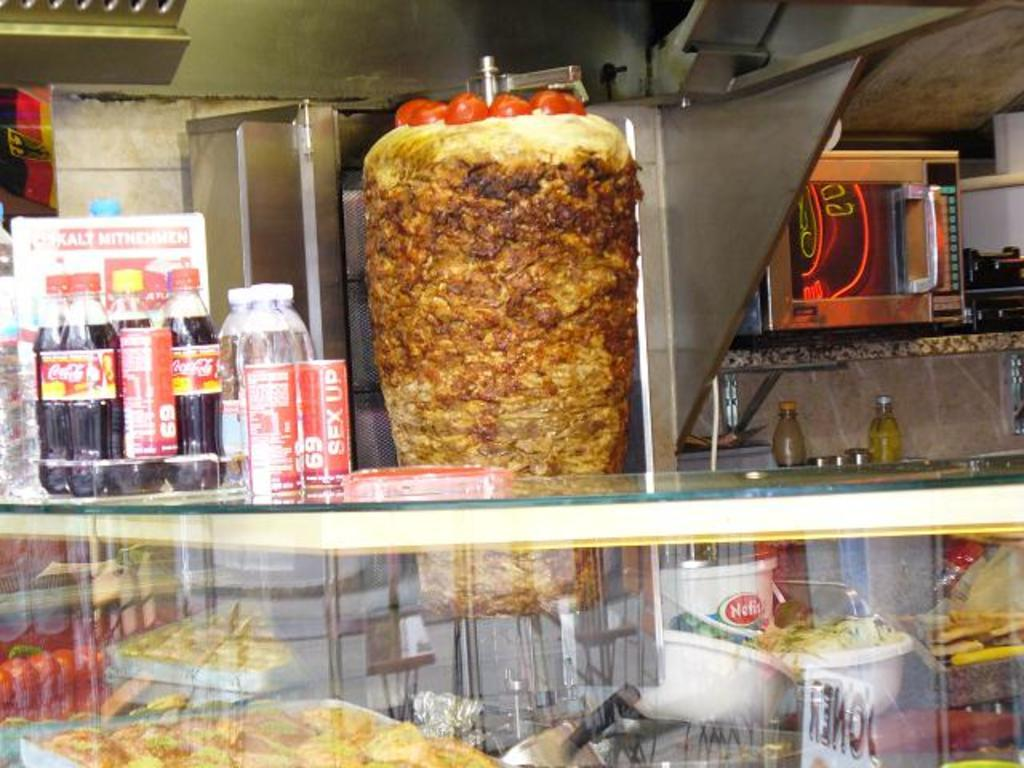What is the main object in the center of the image? There is a cabinet in the center of the image. What can be found inside the cabinet? The cabinet contains food items and drinks. What appliance can be seen in the background of the image? There is a microwave oven in the background of the image. What type of structure is visible in the background? There is a wall in the background of the image. Can you describe the overall scene in the image? The image shows a cabinet with food items and drinks, a microwave oven, and a wall in the background, along with many other items visible. How does the feeling of the uncle affect the boats in the image? There are no boats or feelings of an uncle present in the image. 